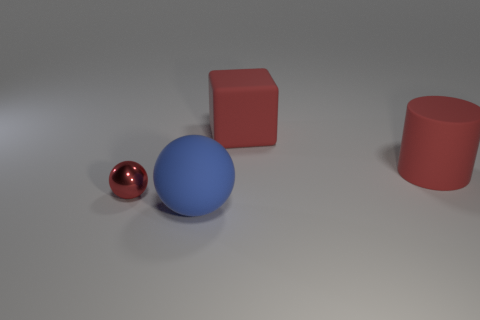Add 3 large purple spheres. How many objects exist? 7 Subtract 0 cyan blocks. How many objects are left? 4 Subtract 1 spheres. How many spheres are left? 1 Subtract all brown blocks. Subtract all cyan spheres. How many blocks are left? 1 Subtract all purple cylinders. How many brown cubes are left? 0 Subtract all cylinders. Subtract all blue rubber cylinders. How many objects are left? 3 Add 3 spheres. How many spheres are left? 5 Add 3 tiny red objects. How many tiny red objects exist? 4 